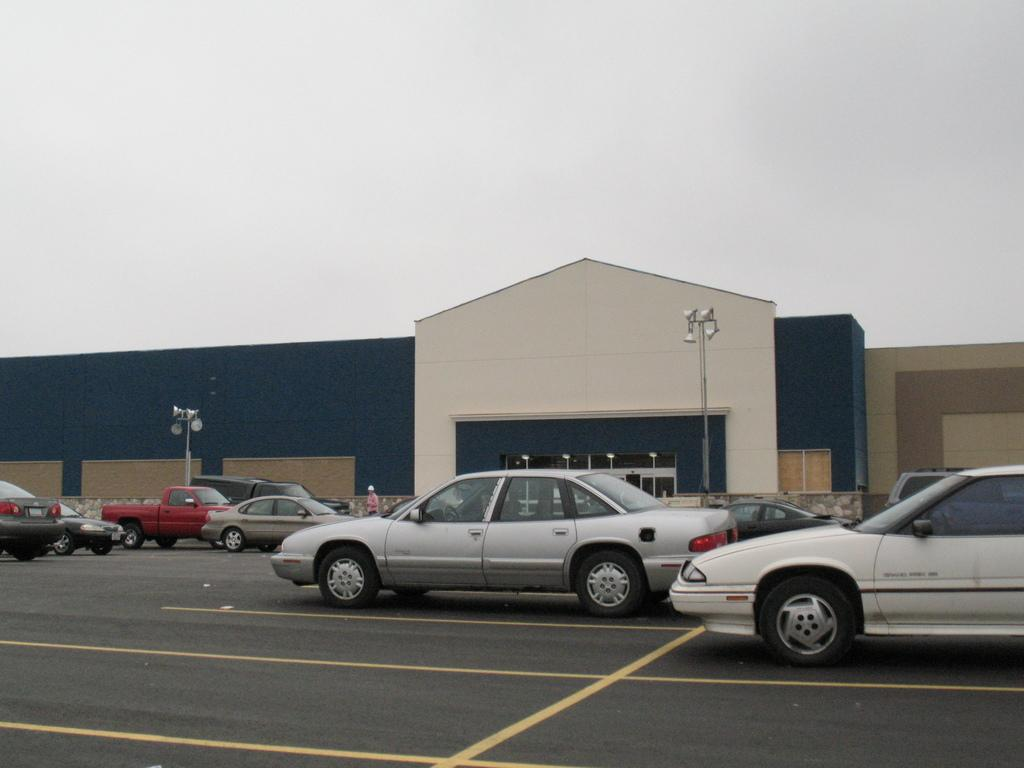What can be seen on the road in the image? There are vehicles on the road in the image. What is located in the background of the image? There is a shed, a person, poles, lights, and a wall in the background of the image. What is visible at the top of the image? The sky is visible at the top of the image. What type of lettuce is growing on the wall in the image? There is no lettuce present in the image; it features vehicles on the road, a shed, a person, poles, lights, and a wall in the background, and the sky at the top. How does the person in the image quiver while walking? There is no indication of the person walking or quivering in the image. 